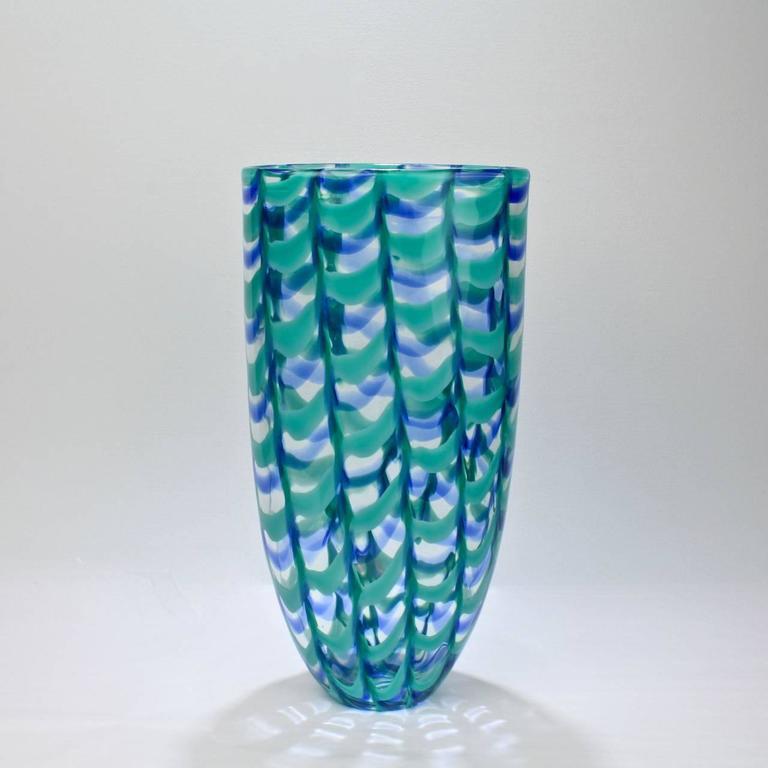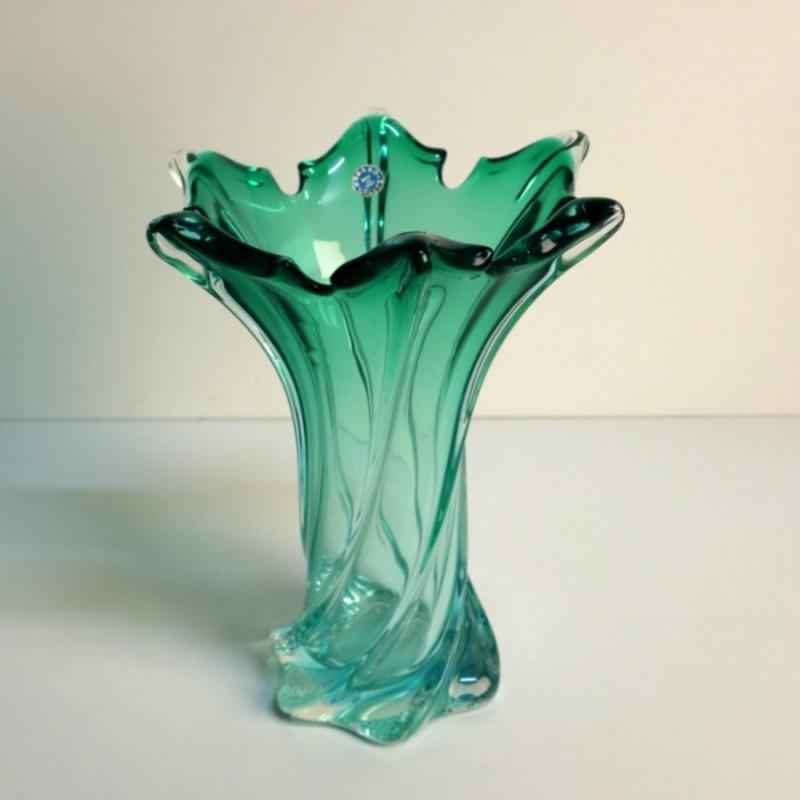The first image is the image on the left, the second image is the image on the right. Analyze the images presented: Is the assertion "Each image shows a vase that flares at the top and has colored glass without a regular pattern." valid? Answer yes or no. No. The first image is the image on the left, the second image is the image on the right. Given the left and right images, does the statement "Both vases are at least party green." hold true? Answer yes or no. Yes. 